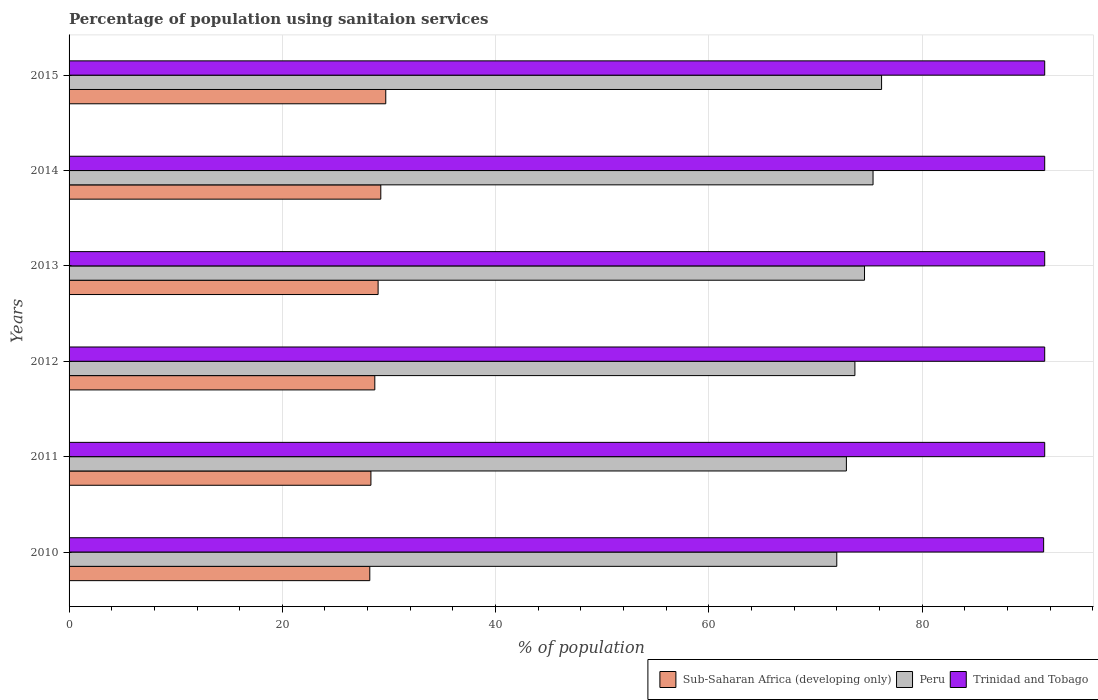Are the number of bars per tick equal to the number of legend labels?
Provide a short and direct response. Yes. What is the label of the 3rd group of bars from the top?
Give a very brief answer. 2013. In how many cases, is the number of bars for a given year not equal to the number of legend labels?
Your answer should be compact. 0. What is the percentage of population using sanitaion services in Peru in 2015?
Give a very brief answer. 76.2. Across all years, what is the maximum percentage of population using sanitaion services in Sub-Saharan Africa (developing only)?
Provide a succinct answer. 29.7. Across all years, what is the minimum percentage of population using sanitaion services in Sub-Saharan Africa (developing only)?
Your response must be concise. 28.2. In which year was the percentage of population using sanitaion services in Peru maximum?
Provide a succinct answer. 2015. In which year was the percentage of population using sanitaion services in Trinidad and Tobago minimum?
Your answer should be very brief. 2010. What is the total percentage of population using sanitaion services in Trinidad and Tobago in the graph?
Keep it short and to the point. 548.9. What is the difference between the percentage of population using sanitaion services in Peru in 2011 and that in 2015?
Offer a very short reply. -3.3. What is the difference between the percentage of population using sanitaion services in Trinidad and Tobago in 2014 and the percentage of population using sanitaion services in Sub-Saharan Africa (developing only) in 2012?
Provide a succinct answer. 62.83. What is the average percentage of population using sanitaion services in Sub-Saharan Africa (developing only) per year?
Ensure brevity in your answer.  28.85. In the year 2011, what is the difference between the percentage of population using sanitaion services in Peru and percentage of population using sanitaion services in Trinidad and Tobago?
Offer a terse response. -18.6. In how many years, is the percentage of population using sanitaion services in Sub-Saharan Africa (developing only) greater than 28 %?
Your answer should be very brief. 6. Is the percentage of population using sanitaion services in Sub-Saharan Africa (developing only) in 2010 less than that in 2012?
Your answer should be compact. Yes. Is the difference between the percentage of population using sanitaion services in Peru in 2014 and 2015 greater than the difference between the percentage of population using sanitaion services in Trinidad and Tobago in 2014 and 2015?
Make the answer very short. No. What is the difference between the highest and the lowest percentage of population using sanitaion services in Peru?
Your answer should be compact. 4.2. In how many years, is the percentage of population using sanitaion services in Sub-Saharan Africa (developing only) greater than the average percentage of population using sanitaion services in Sub-Saharan Africa (developing only) taken over all years?
Give a very brief answer. 3. Is the sum of the percentage of population using sanitaion services in Peru in 2012 and 2015 greater than the maximum percentage of population using sanitaion services in Sub-Saharan Africa (developing only) across all years?
Your response must be concise. Yes. What does the 3rd bar from the top in 2014 represents?
Your response must be concise. Sub-Saharan Africa (developing only). What does the 2nd bar from the bottom in 2011 represents?
Ensure brevity in your answer.  Peru. Is it the case that in every year, the sum of the percentage of population using sanitaion services in Sub-Saharan Africa (developing only) and percentage of population using sanitaion services in Trinidad and Tobago is greater than the percentage of population using sanitaion services in Peru?
Your answer should be compact. Yes. Are all the bars in the graph horizontal?
Keep it short and to the point. Yes. What is the difference between two consecutive major ticks on the X-axis?
Provide a short and direct response. 20. Are the values on the major ticks of X-axis written in scientific E-notation?
Provide a succinct answer. No. How many legend labels are there?
Give a very brief answer. 3. What is the title of the graph?
Give a very brief answer. Percentage of population using sanitaion services. Does "Benin" appear as one of the legend labels in the graph?
Offer a very short reply. No. What is the label or title of the X-axis?
Your answer should be compact. % of population. What is the label or title of the Y-axis?
Your response must be concise. Years. What is the % of population of Sub-Saharan Africa (developing only) in 2010?
Provide a short and direct response. 28.2. What is the % of population in Peru in 2010?
Your answer should be very brief. 72. What is the % of population in Trinidad and Tobago in 2010?
Provide a short and direct response. 91.4. What is the % of population in Sub-Saharan Africa (developing only) in 2011?
Provide a succinct answer. 28.31. What is the % of population of Peru in 2011?
Your answer should be very brief. 72.9. What is the % of population in Trinidad and Tobago in 2011?
Keep it short and to the point. 91.5. What is the % of population of Sub-Saharan Africa (developing only) in 2012?
Provide a short and direct response. 28.67. What is the % of population of Peru in 2012?
Ensure brevity in your answer.  73.7. What is the % of population of Trinidad and Tobago in 2012?
Give a very brief answer. 91.5. What is the % of population of Sub-Saharan Africa (developing only) in 2013?
Provide a succinct answer. 28.98. What is the % of population of Peru in 2013?
Your answer should be compact. 74.6. What is the % of population in Trinidad and Tobago in 2013?
Offer a terse response. 91.5. What is the % of population in Sub-Saharan Africa (developing only) in 2014?
Your answer should be very brief. 29.23. What is the % of population in Peru in 2014?
Provide a short and direct response. 75.4. What is the % of population of Trinidad and Tobago in 2014?
Offer a terse response. 91.5. What is the % of population in Sub-Saharan Africa (developing only) in 2015?
Provide a succinct answer. 29.7. What is the % of population of Peru in 2015?
Ensure brevity in your answer.  76.2. What is the % of population of Trinidad and Tobago in 2015?
Your answer should be compact. 91.5. Across all years, what is the maximum % of population of Sub-Saharan Africa (developing only)?
Your answer should be compact. 29.7. Across all years, what is the maximum % of population of Peru?
Ensure brevity in your answer.  76.2. Across all years, what is the maximum % of population of Trinidad and Tobago?
Provide a short and direct response. 91.5. Across all years, what is the minimum % of population of Sub-Saharan Africa (developing only)?
Provide a succinct answer. 28.2. Across all years, what is the minimum % of population of Trinidad and Tobago?
Your answer should be very brief. 91.4. What is the total % of population of Sub-Saharan Africa (developing only) in the graph?
Keep it short and to the point. 173.11. What is the total % of population of Peru in the graph?
Ensure brevity in your answer.  444.8. What is the total % of population in Trinidad and Tobago in the graph?
Keep it short and to the point. 548.9. What is the difference between the % of population of Sub-Saharan Africa (developing only) in 2010 and that in 2011?
Provide a short and direct response. -0.11. What is the difference between the % of population in Peru in 2010 and that in 2011?
Keep it short and to the point. -0.9. What is the difference between the % of population of Trinidad and Tobago in 2010 and that in 2011?
Give a very brief answer. -0.1. What is the difference between the % of population of Sub-Saharan Africa (developing only) in 2010 and that in 2012?
Ensure brevity in your answer.  -0.47. What is the difference between the % of population in Trinidad and Tobago in 2010 and that in 2012?
Your answer should be compact. -0.1. What is the difference between the % of population of Sub-Saharan Africa (developing only) in 2010 and that in 2013?
Ensure brevity in your answer.  -0.78. What is the difference between the % of population of Peru in 2010 and that in 2013?
Your response must be concise. -2.6. What is the difference between the % of population in Trinidad and Tobago in 2010 and that in 2013?
Provide a succinct answer. -0.1. What is the difference between the % of population of Sub-Saharan Africa (developing only) in 2010 and that in 2014?
Your answer should be compact. -1.03. What is the difference between the % of population in Sub-Saharan Africa (developing only) in 2010 and that in 2015?
Make the answer very short. -1.5. What is the difference between the % of population in Peru in 2010 and that in 2015?
Give a very brief answer. -4.2. What is the difference between the % of population in Trinidad and Tobago in 2010 and that in 2015?
Your answer should be very brief. -0.1. What is the difference between the % of population of Sub-Saharan Africa (developing only) in 2011 and that in 2012?
Your answer should be very brief. -0.37. What is the difference between the % of population in Peru in 2011 and that in 2012?
Give a very brief answer. -0.8. What is the difference between the % of population in Sub-Saharan Africa (developing only) in 2011 and that in 2013?
Offer a terse response. -0.67. What is the difference between the % of population in Sub-Saharan Africa (developing only) in 2011 and that in 2014?
Your answer should be very brief. -0.93. What is the difference between the % of population of Sub-Saharan Africa (developing only) in 2011 and that in 2015?
Provide a succinct answer. -1.39. What is the difference between the % of population in Peru in 2011 and that in 2015?
Provide a short and direct response. -3.3. What is the difference between the % of population of Sub-Saharan Africa (developing only) in 2012 and that in 2013?
Your answer should be very brief. -0.31. What is the difference between the % of population in Peru in 2012 and that in 2013?
Offer a terse response. -0.9. What is the difference between the % of population in Sub-Saharan Africa (developing only) in 2012 and that in 2014?
Your answer should be very brief. -0.56. What is the difference between the % of population in Trinidad and Tobago in 2012 and that in 2014?
Your answer should be very brief. 0. What is the difference between the % of population of Sub-Saharan Africa (developing only) in 2012 and that in 2015?
Your response must be concise. -1.03. What is the difference between the % of population in Peru in 2012 and that in 2015?
Provide a short and direct response. -2.5. What is the difference between the % of population of Sub-Saharan Africa (developing only) in 2013 and that in 2014?
Keep it short and to the point. -0.25. What is the difference between the % of population in Peru in 2013 and that in 2014?
Ensure brevity in your answer.  -0.8. What is the difference between the % of population of Trinidad and Tobago in 2013 and that in 2014?
Offer a terse response. 0. What is the difference between the % of population in Sub-Saharan Africa (developing only) in 2013 and that in 2015?
Ensure brevity in your answer.  -0.72. What is the difference between the % of population in Sub-Saharan Africa (developing only) in 2014 and that in 2015?
Offer a very short reply. -0.47. What is the difference between the % of population in Peru in 2014 and that in 2015?
Offer a very short reply. -0.8. What is the difference between the % of population in Trinidad and Tobago in 2014 and that in 2015?
Offer a very short reply. 0. What is the difference between the % of population in Sub-Saharan Africa (developing only) in 2010 and the % of population in Peru in 2011?
Offer a very short reply. -44.7. What is the difference between the % of population in Sub-Saharan Africa (developing only) in 2010 and the % of population in Trinidad and Tobago in 2011?
Give a very brief answer. -63.3. What is the difference between the % of population of Peru in 2010 and the % of population of Trinidad and Tobago in 2011?
Your answer should be very brief. -19.5. What is the difference between the % of population in Sub-Saharan Africa (developing only) in 2010 and the % of population in Peru in 2012?
Your answer should be very brief. -45.5. What is the difference between the % of population of Sub-Saharan Africa (developing only) in 2010 and the % of population of Trinidad and Tobago in 2012?
Provide a succinct answer. -63.3. What is the difference between the % of population in Peru in 2010 and the % of population in Trinidad and Tobago in 2012?
Provide a short and direct response. -19.5. What is the difference between the % of population of Sub-Saharan Africa (developing only) in 2010 and the % of population of Peru in 2013?
Your answer should be compact. -46.4. What is the difference between the % of population in Sub-Saharan Africa (developing only) in 2010 and the % of population in Trinidad and Tobago in 2013?
Your answer should be compact. -63.3. What is the difference between the % of population in Peru in 2010 and the % of population in Trinidad and Tobago in 2013?
Provide a succinct answer. -19.5. What is the difference between the % of population of Sub-Saharan Africa (developing only) in 2010 and the % of population of Peru in 2014?
Keep it short and to the point. -47.2. What is the difference between the % of population of Sub-Saharan Africa (developing only) in 2010 and the % of population of Trinidad and Tobago in 2014?
Keep it short and to the point. -63.3. What is the difference between the % of population in Peru in 2010 and the % of population in Trinidad and Tobago in 2014?
Your answer should be compact. -19.5. What is the difference between the % of population in Sub-Saharan Africa (developing only) in 2010 and the % of population in Peru in 2015?
Provide a succinct answer. -48. What is the difference between the % of population of Sub-Saharan Africa (developing only) in 2010 and the % of population of Trinidad and Tobago in 2015?
Provide a short and direct response. -63.3. What is the difference between the % of population in Peru in 2010 and the % of population in Trinidad and Tobago in 2015?
Your response must be concise. -19.5. What is the difference between the % of population in Sub-Saharan Africa (developing only) in 2011 and the % of population in Peru in 2012?
Offer a very short reply. -45.39. What is the difference between the % of population in Sub-Saharan Africa (developing only) in 2011 and the % of population in Trinidad and Tobago in 2012?
Offer a very short reply. -63.19. What is the difference between the % of population of Peru in 2011 and the % of population of Trinidad and Tobago in 2012?
Provide a succinct answer. -18.6. What is the difference between the % of population in Sub-Saharan Africa (developing only) in 2011 and the % of population in Peru in 2013?
Your response must be concise. -46.29. What is the difference between the % of population in Sub-Saharan Africa (developing only) in 2011 and the % of population in Trinidad and Tobago in 2013?
Offer a very short reply. -63.19. What is the difference between the % of population in Peru in 2011 and the % of population in Trinidad and Tobago in 2013?
Provide a short and direct response. -18.6. What is the difference between the % of population of Sub-Saharan Africa (developing only) in 2011 and the % of population of Peru in 2014?
Your answer should be compact. -47.09. What is the difference between the % of population in Sub-Saharan Africa (developing only) in 2011 and the % of population in Trinidad and Tobago in 2014?
Your answer should be very brief. -63.19. What is the difference between the % of population in Peru in 2011 and the % of population in Trinidad and Tobago in 2014?
Your answer should be very brief. -18.6. What is the difference between the % of population in Sub-Saharan Africa (developing only) in 2011 and the % of population in Peru in 2015?
Ensure brevity in your answer.  -47.89. What is the difference between the % of population of Sub-Saharan Africa (developing only) in 2011 and the % of population of Trinidad and Tobago in 2015?
Make the answer very short. -63.19. What is the difference between the % of population of Peru in 2011 and the % of population of Trinidad and Tobago in 2015?
Your answer should be very brief. -18.6. What is the difference between the % of population of Sub-Saharan Africa (developing only) in 2012 and the % of population of Peru in 2013?
Offer a very short reply. -45.93. What is the difference between the % of population in Sub-Saharan Africa (developing only) in 2012 and the % of population in Trinidad and Tobago in 2013?
Your answer should be very brief. -62.83. What is the difference between the % of population of Peru in 2012 and the % of population of Trinidad and Tobago in 2013?
Keep it short and to the point. -17.8. What is the difference between the % of population of Sub-Saharan Africa (developing only) in 2012 and the % of population of Peru in 2014?
Keep it short and to the point. -46.73. What is the difference between the % of population of Sub-Saharan Africa (developing only) in 2012 and the % of population of Trinidad and Tobago in 2014?
Offer a very short reply. -62.83. What is the difference between the % of population of Peru in 2012 and the % of population of Trinidad and Tobago in 2014?
Offer a very short reply. -17.8. What is the difference between the % of population in Sub-Saharan Africa (developing only) in 2012 and the % of population in Peru in 2015?
Offer a terse response. -47.53. What is the difference between the % of population in Sub-Saharan Africa (developing only) in 2012 and the % of population in Trinidad and Tobago in 2015?
Your response must be concise. -62.83. What is the difference between the % of population of Peru in 2012 and the % of population of Trinidad and Tobago in 2015?
Your response must be concise. -17.8. What is the difference between the % of population in Sub-Saharan Africa (developing only) in 2013 and the % of population in Peru in 2014?
Provide a succinct answer. -46.42. What is the difference between the % of population in Sub-Saharan Africa (developing only) in 2013 and the % of population in Trinidad and Tobago in 2014?
Ensure brevity in your answer.  -62.52. What is the difference between the % of population of Peru in 2013 and the % of population of Trinidad and Tobago in 2014?
Make the answer very short. -16.9. What is the difference between the % of population in Sub-Saharan Africa (developing only) in 2013 and the % of population in Peru in 2015?
Provide a succinct answer. -47.22. What is the difference between the % of population of Sub-Saharan Africa (developing only) in 2013 and the % of population of Trinidad and Tobago in 2015?
Offer a terse response. -62.52. What is the difference between the % of population of Peru in 2013 and the % of population of Trinidad and Tobago in 2015?
Ensure brevity in your answer.  -16.9. What is the difference between the % of population in Sub-Saharan Africa (developing only) in 2014 and the % of population in Peru in 2015?
Make the answer very short. -46.97. What is the difference between the % of population of Sub-Saharan Africa (developing only) in 2014 and the % of population of Trinidad and Tobago in 2015?
Make the answer very short. -62.27. What is the difference between the % of population in Peru in 2014 and the % of population in Trinidad and Tobago in 2015?
Provide a short and direct response. -16.1. What is the average % of population in Sub-Saharan Africa (developing only) per year?
Your answer should be compact. 28.85. What is the average % of population of Peru per year?
Keep it short and to the point. 74.13. What is the average % of population in Trinidad and Tobago per year?
Your answer should be very brief. 91.48. In the year 2010, what is the difference between the % of population in Sub-Saharan Africa (developing only) and % of population in Peru?
Give a very brief answer. -43.8. In the year 2010, what is the difference between the % of population of Sub-Saharan Africa (developing only) and % of population of Trinidad and Tobago?
Provide a short and direct response. -63.2. In the year 2010, what is the difference between the % of population of Peru and % of population of Trinidad and Tobago?
Your answer should be compact. -19.4. In the year 2011, what is the difference between the % of population in Sub-Saharan Africa (developing only) and % of population in Peru?
Offer a very short reply. -44.59. In the year 2011, what is the difference between the % of population in Sub-Saharan Africa (developing only) and % of population in Trinidad and Tobago?
Offer a terse response. -63.19. In the year 2011, what is the difference between the % of population of Peru and % of population of Trinidad and Tobago?
Keep it short and to the point. -18.6. In the year 2012, what is the difference between the % of population of Sub-Saharan Africa (developing only) and % of population of Peru?
Keep it short and to the point. -45.03. In the year 2012, what is the difference between the % of population in Sub-Saharan Africa (developing only) and % of population in Trinidad and Tobago?
Provide a short and direct response. -62.83. In the year 2012, what is the difference between the % of population in Peru and % of population in Trinidad and Tobago?
Your answer should be compact. -17.8. In the year 2013, what is the difference between the % of population in Sub-Saharan Africa (developing only) and % of population in Peru?
Your response must be concise. -45.62. In the year 2013, what is the difference between the % of population in Sub-Saharan Africa (developing only) and % of population in Trinidad and Tobago?
Provide a succinct answer. -62.52. In the year 2013, what is the difference between the % of population in Peru and % of population in Trinidad and Tobago?
Offer a very short reply. -16.9. In the year 2014, what is the difference between the % of population of Sub-Saharan Africa (developing only) and % of population of Peru?
Your answer should be compact. -46.17. In the year 2014, what is the difference between the % of population of Sub-Saharan Africa (developing only) and % of population of Trinidad and Tobago?
Keep it short and to the point. -62.27. In the year 2014, what is the difference between the % of population in Peru and % of population in Trinidad and Tobago?
Provide a short and direct response. -16.1. In the year 2015, what is the difference between the % of population of Sub-Saharan Africa (developing only) and % of population of Peru?
Ensure brevity in your answer.  -46.5. In the year 2015, what is the difference between the % of population of Sub-Saharan Africa (developing only) and % of population of Trinidad and Tobago?
Give a very brief answer. -61.8. In the year 2015, what is the difference between the % of population of Peru and % of population of Trinidad and Tobago?
Provide a short and direct response. -15.3. What is the ratio of the % of population of Sub-Saharan Africa (developing only) in 2010 to that in 2011?
Your answer should be very brief. 1. What is the ratio of the % of population of Sub-Saharan Africa (developing only) in 2010 to that in 2012?
Make the answer very short. 0.98. What is the ratio of the % of population of Peru in 2010 to that in 2012?
Offer a terse response. 0.98. What is the ratio of the % of population in Sub-Saharan Africa (developing only) in 2010 to that in 2013?
Offer a very short reply. 0.97. What is the ratio of the % of population of Peru in 2010 to that in 2013?
Your response must be concise. 0.97. What is the ratio of the % of population in Trinidad and Tobago in 2010 to that in 2013?
Your response must be concise. 1. What is the ratio of the % of population in Sub-Saharan Africa (developing only) in 2010 to that in 2014?
Ensure brevity in your answer.  0.96. What is the ratio of the % of population in Peru in 2010 to that in 2014?
Offer a terse response. 0.95. What is the ratio of the % of population of Sub-Saharan Africa (developing only) in 2010 to that in 2015?
Keep it short and to the point. 0.95. What is the ratio of the % of population in Peru in 2010 to that in 2015?
Make the answer very short. 0.94. What is the ratio of the % of population of Trinidad and Tobago in 2010 to that in 2015?
Offer a very short reply. 1. What is the ratio of the % of population of Sub-Saharan Africa (developing only) in 2011 to that in 2012?
Offer a terse response. 0.99. What is the ratio of the % of population in Sub-Saharan Africa (developing only) in 2011 to that in 2013?
Your answer should be compact. 0.98. What is the ratio of the % of population of Peru in 2011 to that in 2013?
Provide a short and direct response. 0.98. What is the ratio of the % of population in Trinidad and Tobago in 2011 to that in 2013?
Make the answer very short. 1. What is the ratio of the % of population in Sub-Saharan Africa (developing only) in 2011 to that in 2014?
Make the answer very short. 0.97. What is the ratio of the % of population of Peru in 2011 to that in 2014?
Your response must be concise. 0.97. What is the ratio of the % of population in Trinidad and Tobago in 2011 to that in 2014?
Offer a very short reply. 1. What is the ratio of the % of population in Sub-Saharan Africa (developing only) in 2011 to that in 2015?
Give a very brief answer. 0.95. What is the ratio of the % of population in Peru in 2011 to that in 2015?
Provide a short and direct response. 0.96. What is the ratio of the % of population of Trinidad and Tobago in 2011 to that in 2015?
Offer a very short reply. 1. What is the ratio of the % of population in Sub-Saharan Africa (developing only) in 2012 to that in 2013?
Make the answer very short. 0.99. What is the ratio of the % of population of Peru in 2012 to that in 2013?
Your response must be concise. 0.99. What is the ratio of the % of population of Trinidad and Tobago in 2012 to that in 2013?
Your response must be concise. 1. What is the ratio of the % of population of Sub-Saharan Africa (developing only) in 2012 to that in 2014?
Ensure brevity in your answer.  0.98. What is the ratio of the % of population of Peru in 2012 to that in 2014?
Your response must be concise. 0.98. What is the ratio of the % of population of Sub-Saharan Africa (developing only) in 2012 to that in 2015?
Your response must be concise. 0.97. What is the ratio of the % of population in Peru in 2012 to that in 2015?
Keep it short and to the point. 0.97. What is the ratio of the % of population of Trinidad and Tobago in 2012 to that in 2015?
Your answer should be compact. 1. What is the ratio of the % of population in Sub-Saharan Africa (developing only) in 2013 to that in 2014?
Ensure brevity in your answer.  0.99. What is the ratio of the % of population of Sub-Saharan Africa (developing only) in 2013 to that in 2015?
Offer a very short reply. 0.98. What is the ratio of the % of population of Sub-Saharan Africa (developing only) in 2014 to that in 2015?
Your answer should be compact. 0.98. What is the ratio of the % of population in Trinidad and Tobago in 2014 to that in 2015?
Make the answer very short. 1. What is the difference between the highest and the second highest % of population in Sub-Saharan Africa (developing only)?
Keep it short and to the point. 0.47. What is the difference between the highest and the second highest % of population of Trinidad and Tobago?
Provide a short and direct response. 0. What is the difference between the highest and the lowest % of population in Sub-Saharan Africa (developing only)?
Offer a very short reply. 1.5. 